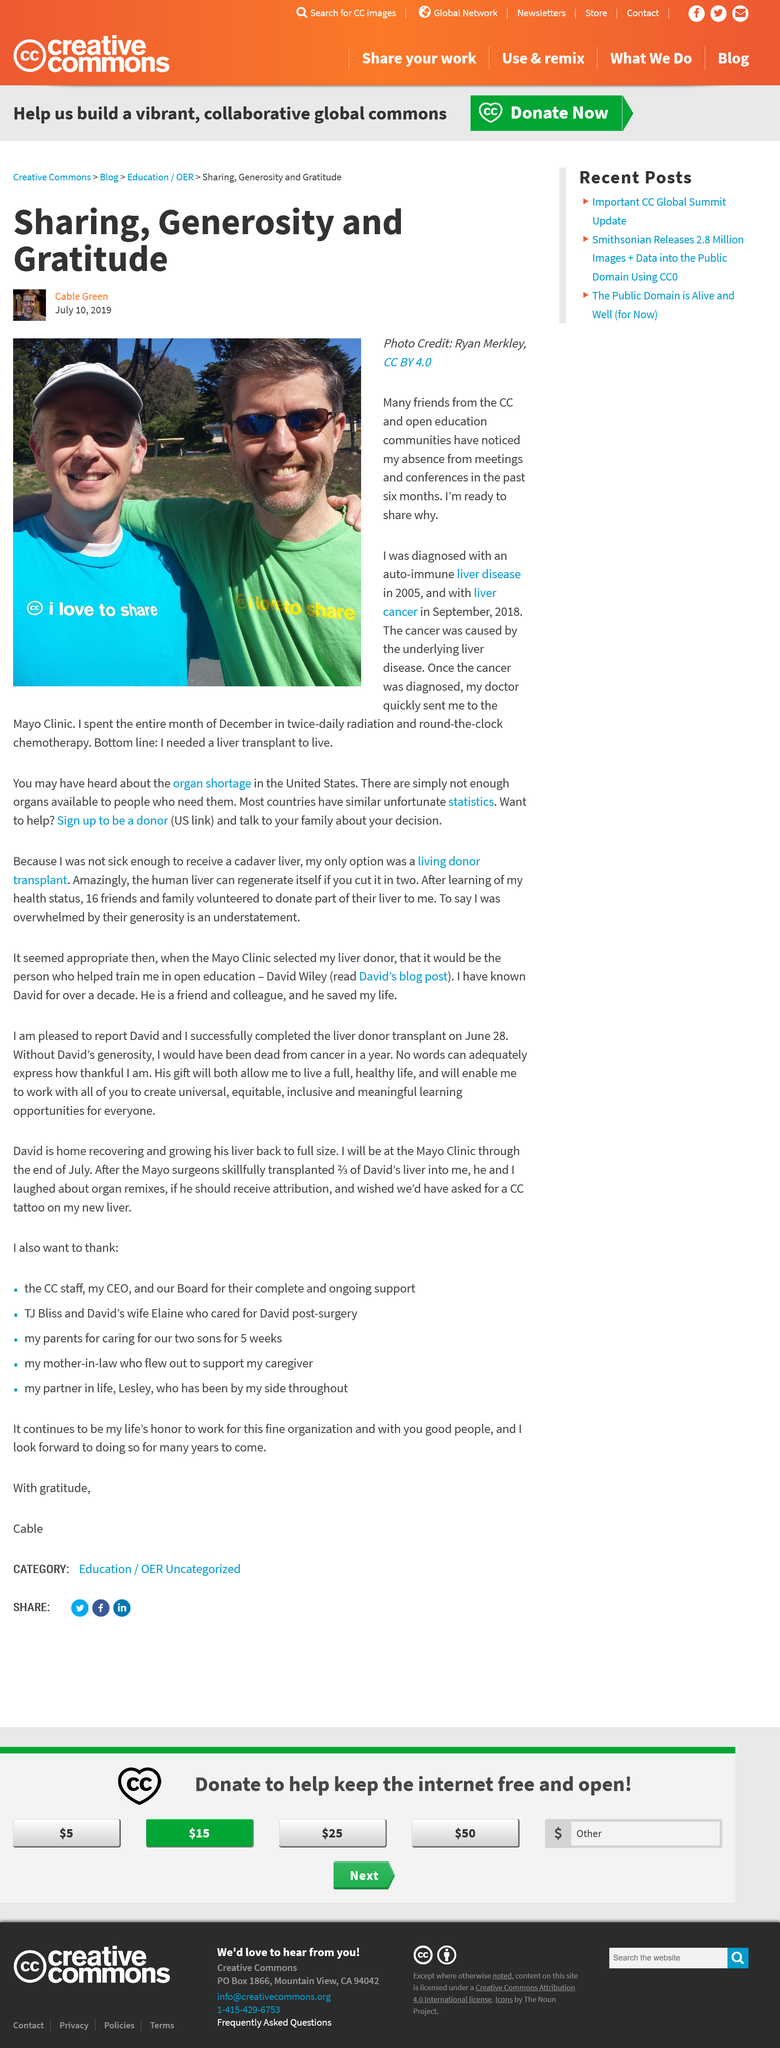Highlight a few significant elements in this photo. The author addresses the CC and open education communities in this article. Despite the administration of twice-daily radiation therapy and continuous chemotherapy, the cancer was not brought under control. The cancer was diagnosed 13 years after it was first diagnosed. 